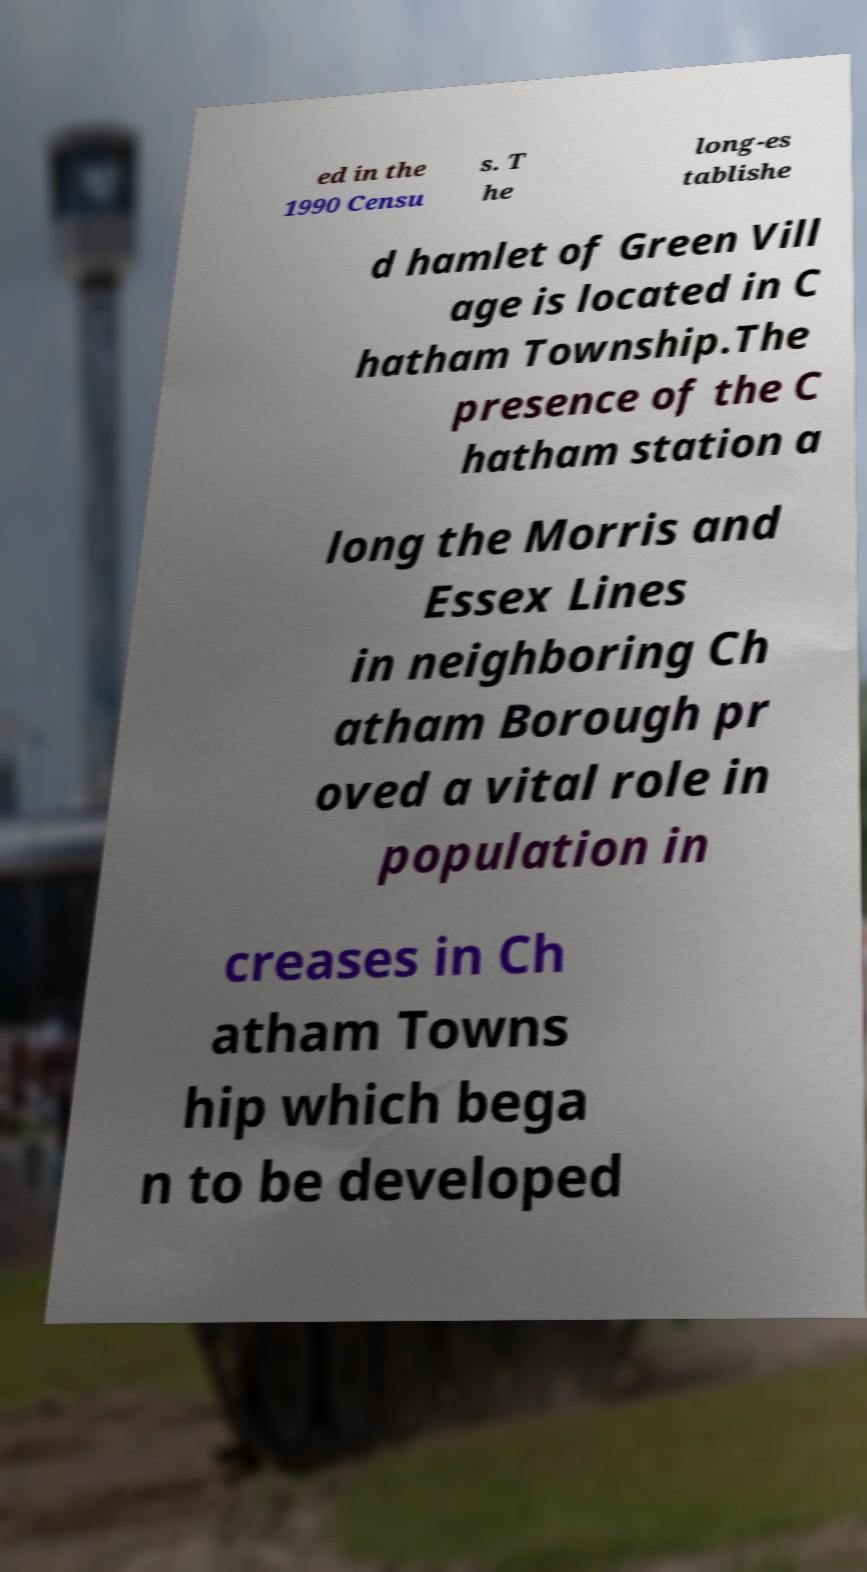What messages or text are displayed in this image? I need them in a readable, typed format. ed in the 1990 Censu s. T he long-es tablishe d hamlet of Green Vill age is located in C hatham Township.The presence of the C hatham station a long the Morris and Essex Lines in neighboring Ch atham Borough pr oved a vital role in population in creases in Ch atham Towns hip which bega n to be developed 